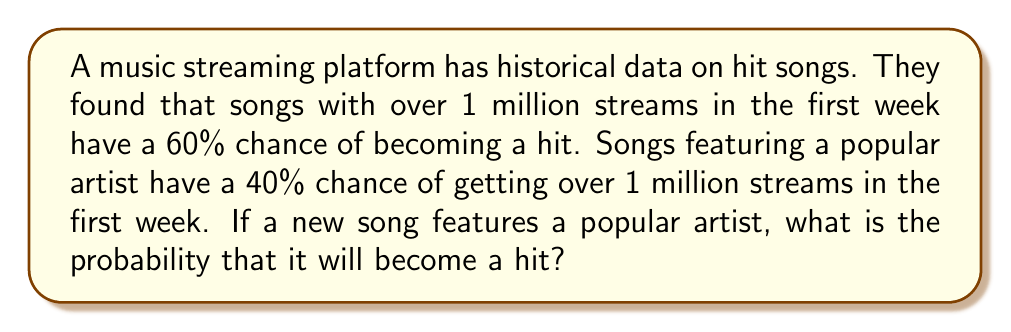Show me your answer to this math problem. Let's approach this step-by-step using conditional probability:

1) Define events:
   A: The song becomes a hit
   B: The song gets over 1 million streams in the first week
   C: The song features a popular artist

2) Given probabilities:
   $P(A|B) = 0.60$ (probability of becoming a hit given over 1 million streams)
   $P(B|C) = 0.40$ (probability of over 1 million streams given a popular artist)

3) We want to find $P(A|C)$, the probability of becoming a hit given a popular artist.

4) We can use the law of total probability:

   $P(A|C) = P(A|B,C) \cdot P(B|C) + P(A|\overline{B},C) \cdot P(\overline{B}|C)$

5) We know $P(B|C) = 0.40$, so $P(\overline{B}|C) = 1 - 0.40 = 0.60$

6) We assume $P(A|B,C) = P(A|B) = 0.60$ (the probability of becoming a hit given over 1 million streams is independent of featuring a popular artist)

7) We don't know $P(A|\overline{B},C)$, but we can assume it's lower than $P(A|B)$. Let's estimate it as half of $P(A|B)$, so $P(A|\overline{B},C) = 0.30$

8) Now we can calculate:

   $P(A|C) = 0.60 \cdot 0.40 + 0.30 \cdot 0.60 = 0.24 + 0.18 = 0.42$

Therefore, the probability of the song becoming a hit is approximately 42%.
Answer: 0.42 or 42% 